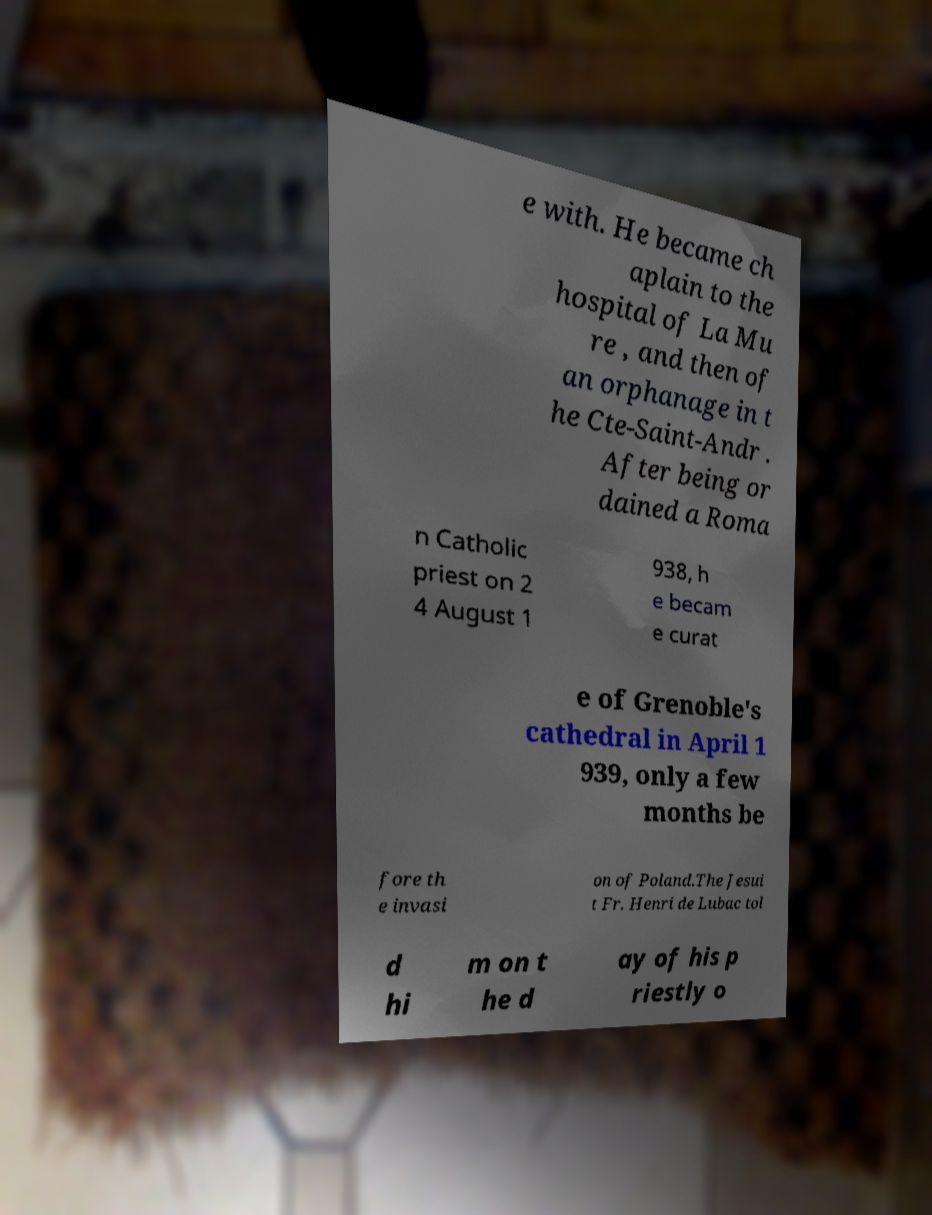I need the written content from this picture converted into text. Can you do that? e with. He became ch aplain to the hospital of La Mu re , and then of an orphanage in t he Cte-Saint-Andr . After being or dained a Roma n Catholic priest on 2 4 August 1 938, h e becam e curat e of Grenoble's cathedral in April 1 939, only a few months be fore th e invasi on of Poland.The Jesui t Fr. Henri de Lubac tol d hi m on t he d ay of his p riestly o 